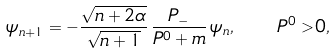<formula> <loc_0><loc_0><loc_500><loc_500>\psi _ { n + 1 } = - \frac { \sqrt { n + 2 \alpha } } { \sqrt { n + 1 } } \, \frac { P _ { - } } { P ^ { 0 } + m } \, \psi _ { n } , \quad P ^ { 0 } > 0 ,</formula> 